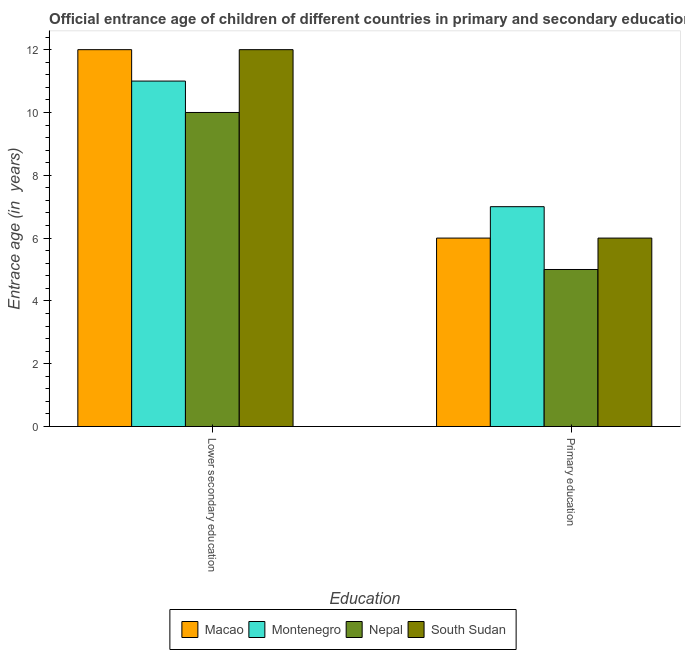How many different coloured bars are there?
Offer a very short reply. 4. How many bars are there on the 1st tick from the left?
Your response must be concise. 4. How many bars are there on the 2nd tick from the right?
Your answer should be very brief. 4. What is the label of the 1st group of bars from the left?
Offer a terse response. Lower secondary education. What is the entrance age of children in lower secondary education in Montenegro?
Offer a terse response. 11. Across all countries, what is the maximum entrance age of chiildren in primary education?
Your answer should be very brief. 7. Across all countries, what is the minimum entrance age of children in lower secondary education?
Give a very brief answer. 10. In which country was the entrance age of children in lower secondary education maximum?
Provide a succinct answer. Macao. In which country was the entrance age of children in lower secondary education minimum?
Give a very brief answer. Nepal. What is the total entrance age of children in lower secondary education in the graph?
Your answer should be compact. 45. What is the difference between the entrance age of chiildren in primary education in South Sudan and that in Montenegro?
Make the answer very short. -1. What is the difference between the entrance age of children in lower secondary education in Macao and the entrance age of chiildren in primary education in Montenegro?
Your answer should be very brief. 5. What is the difference between the entrance age of children in lower secondary education and entrance age of chiildren in primary education in Nepal?
Offer a terse response. 5. In how many countries, is the entrance age of children in lower secondary education greater than 4.8 years?
Make the answer very short. 4. What does the 4th bar from the left in Primary education represents?
Make the answer very short. South Sudan. What does the 4th bar from the right in Primary education represents?
Make the answer very short. Macao. How many bars are there?
Provide a succinct answer. 8. Are all the bars in the graph horizontal?
Your answer should be compact. No. How many countries are there in the graph?
Your answer should be compact. 4. What is the difference between two consecutive major ticks on the Y-axis?
Offer a terse response. 2. Are the values on the major ticks of Y-axis written in scientific E-notation?
Offer a very short reply. No. How many legend labels are there?
Give a very brief answer. 4. What is the title of the graph?
Offer a very short reply. Official entrance age of children of different countries in primary and secondary education. Does "Kenya" appear as one of the legend labels in the graph?
Keep it short and to the point. No. What is the label or title of the X-axis?
Keep it short and to the point. Education. What is the label or title of the Y-axis?
Keep it short and to the point. Entrace age (in  years). What is the Entrace age (in  years) in Nepal in Lower secondary education?
Keep it short and to the point. 10. What is the Entrace age (in  years) of South Sudan in Lower secondary education?
Ensure brevity in your answer.  12. What is the Entrace age (in  years) in Macao in Primary education?
Offer a very short reply. 6. What is the Entrace age (in  years) in Nepal in Primary education?
Ensure brevity in your answer.  5. Across all Education, what is the maximum Entrace age (in  years) of Macao?
Offer a very short reply. 12. Across all Education, what is the maximum Entrace age (in  years) in Montenegro?
Keep it short and to the point. 11. Across all Education, what is the maximum Entrace age (in  years) of South Sudan?
Keep it short and to the point. 12. Across all Education, what is the minimum Entrace age (in  years) in Montenegro?
Ensure brevity in your answer.  7. Across all Education, what is the minimum Entrace age (in  years) in South Sudan?
Give a very brief answer. 6. What is the total Entrace age (in  years) of Montenegro in the graph?
Offer a terse response. 18. What is the total Entrace age (in  years) of Nepal in the graph?
Your response must be concise. 15. What is the total Entrace age (in  years) in South Sudan in the graph?
Make the answer very short. 18. What is the difference between the Entrace age (in  years) of Montenegro in Lower secondary education and that in Primary education?
Offer a very short reply. 4. What is the difference between the Entrace age (in  years) in South Sudan in Lower secondary education and that in Primary education?
Provide a short and direct response. 6. What is the difference between the Entrace age (in  years) in Macao in Lower secondary education and the Entrace age (in  years) in Nepal in Primary education?
Provide a short and direct response. 7. What is the difference between the Entrace age (in  years) in Macao in Lower secondary education and the Entrace age (in  years) in South Sudan in Primary education?
Offer a very short reply. 6. What is the difference between the Entrace age (in  years) in Montenegro in Lower secondary education and the Entrace age (in  years) in Nepal in Primary education?
Your answer should be very brief. 6. What is the average Entrace age (in  years) of South Sudan per Education?
Offer a terse response. 9. What is the difference between the Entrace age (in  years) of Macao and Entrace age (in  years) of Montenegro in Lower secondary education?
Offer a very short reply. 1. What is the difference between the Entrace age (in  years) of Macao and Entrace age (in  years) of Nepal in Lower secondary education?
Provide a short and direct response. 2. What is the difference between the Entrace age (in  years) of Montenegro and Entrace age (in  years) of South Sudan in Lower secondary education?
Offer a terse response. -1. What is the difference between the Entrace age (in  years) in Montenegro and Entrace age (in  years) in South Sudan in Primary education?
Your answer should be very brief. 1. What is the difference between the Entrace age (in  years) of Nepal and Entrace age (in  years) of South Sudan in Primary education?
Your response must be concise. -1. What is the ratio of the Entrace age (in  years) of Montenegro in Lower secondary education to that in Primary education?
Offer a terse response. 1.57. What is the difference between the highest and the second highest Entrace age (in  years) in Macao?
Ensure brevity in your answer.  6. What is the difference between the highest and the lowest Entrace age (in  years) of Macao?
Offer a very short reply. 6. What is the difference between the highest and the lowest Entrace age (in  years) in Nepal?
Provide a short and direct response. 5. What is the difference between the highest and the lowest Entrace age (in  years) in South Sudan?
Your response must be concise. 6. 